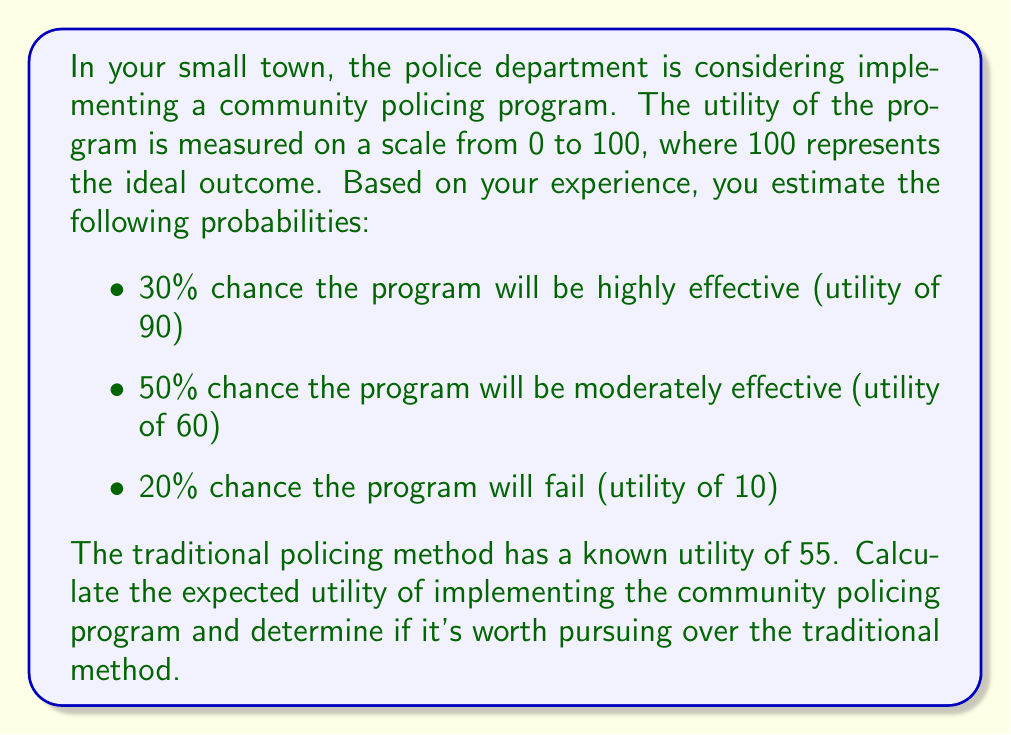Show me your answer to this math problem. To solve this problem, we need to calculate the expected utility of the community policing program and compare it to the utility of the traditional method.

1. Calculate the expected utility of the community policing program:

The expected utility is the sum of each possible outcome multiplied by its probability.

Let $E(U)$ be the expected utility.

$$E(U) = (0.30 \times 90) + (0.50 \times 60) + (0.20 \times 10)$$

Breaking it down step-by-step:
$$E(U) = 27 + 30 + 2$$
$$E(U) = 59$$

2. Compare the expected utility to the traditional method:

The traditional method has a known utility of 55.
The community policing program has an expected utility of 59.

Since 59 > 55, the community policing program has a higher expected utility.

3. Determine if it's worth pursuing:

The difference in utility is:
$$59 - 55 = 4$$

This means the community policing program is expected to provide 4 more utility points than the traditional method.
Answer: The expected utility of implementing the community policing program is 59. Since this is greater than the utility of the traditional method (55), it is worth pursuing the community policing program over the traditional method. 